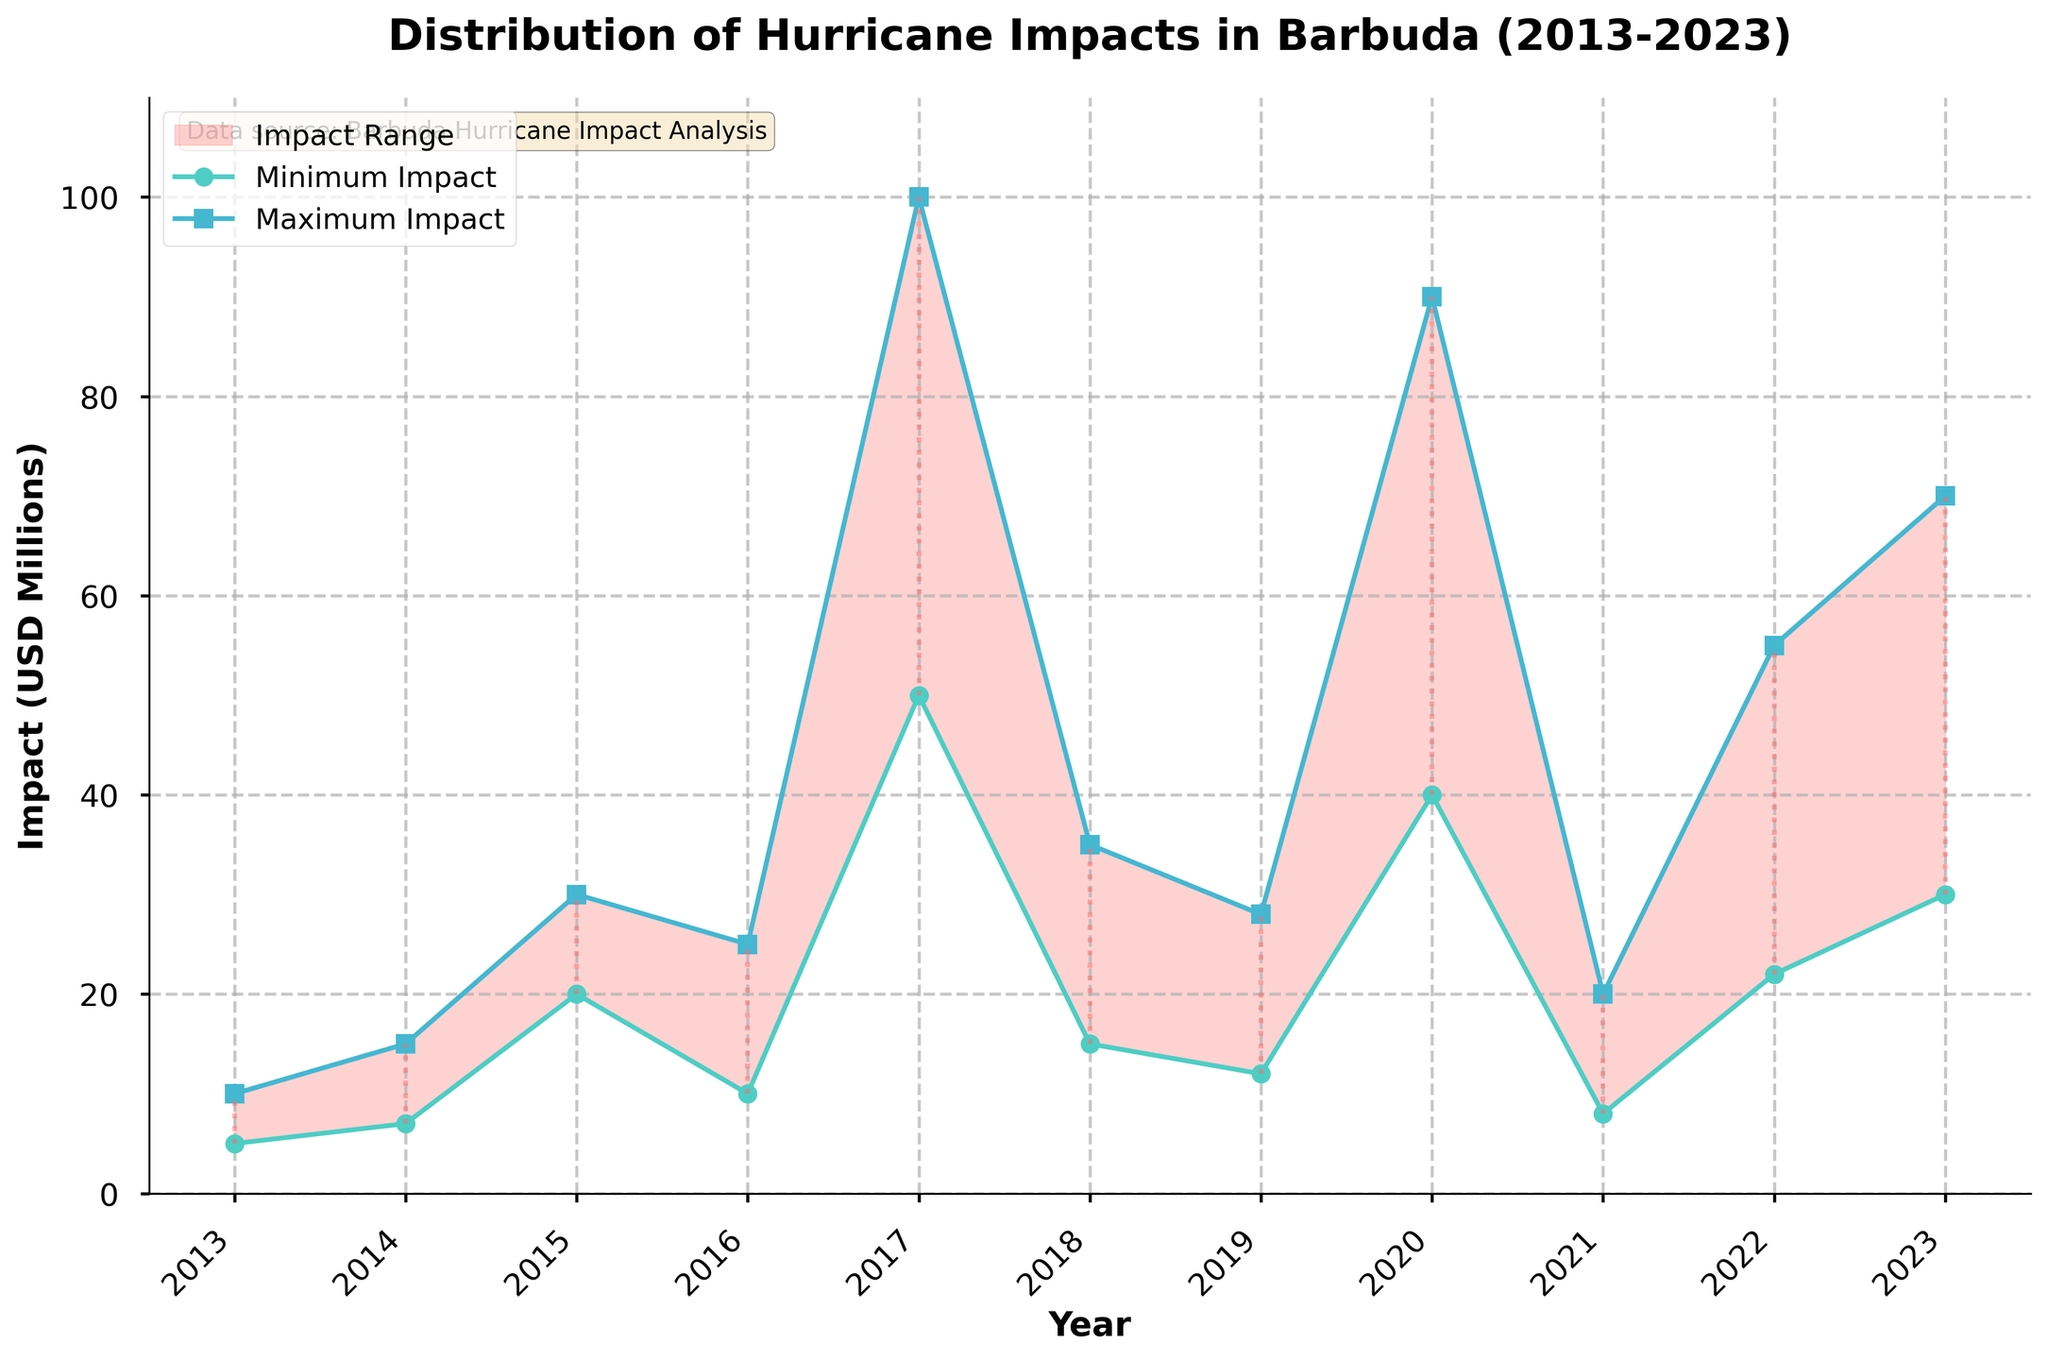What is the title of the chart? The title is provided at the top of the chart. By reading it, we can understand what the chart is about.
Answer: Distribution of Hurricane Impacts in Barbuda (2013-2023) How many years are covered in the chart? The x-axis of the chart lists the years, beginning at 2013 and ending at 2023, giving us the total number of years covered.
Answer: 11 years Which year experienced the maximum possible impact? By looking at the highest point on the maximum impact line and referring to the corresponding year on the x-axis, we find the year with the maximum impact.
Answer: 2017 What is the range of hurricane impact in 2016? The range is found by subtracting the minimum impact from the maximum impact for a given year. For 2016, it is 25 - 10 = 15 million USD.
Answer: 15 million USD Which year had the smallest range of hurricane impact? By comparing the heights of the vertical lines for each year's range, we identify the smallest range.
Answer: 2021 How has the average maximum impact changed between the first (2013) and last year (2023)? Calculate the difference in average maximum impact between 2013 and 2023. First calculate the averages: (10) for 2013 and (70) for 2023. The change is 70 - 10.
Answer: Increased by 60 million USD Which year had a higher minimum impact: 2014 or 2018? By comparing the height of the points on the minimum impact line for 2014 and 2018, we determine which year had a higher minimum impact.
Answer: 2014 What is the difference in the maximum impacts between 2017 and 2020? By looking at the maximum impact values for 2017 (100 million USD) and 2020 (90 million USD) and subtracting the former from the latter.
Answer: 10 million USD What trend can be observed from the maximum impact values over the years? By looking at the general direction of the maximum impact line from left to right, it can be deduced if the values are generally increasing, decreasing, or remaining stable.
Answer: Generally increasing 